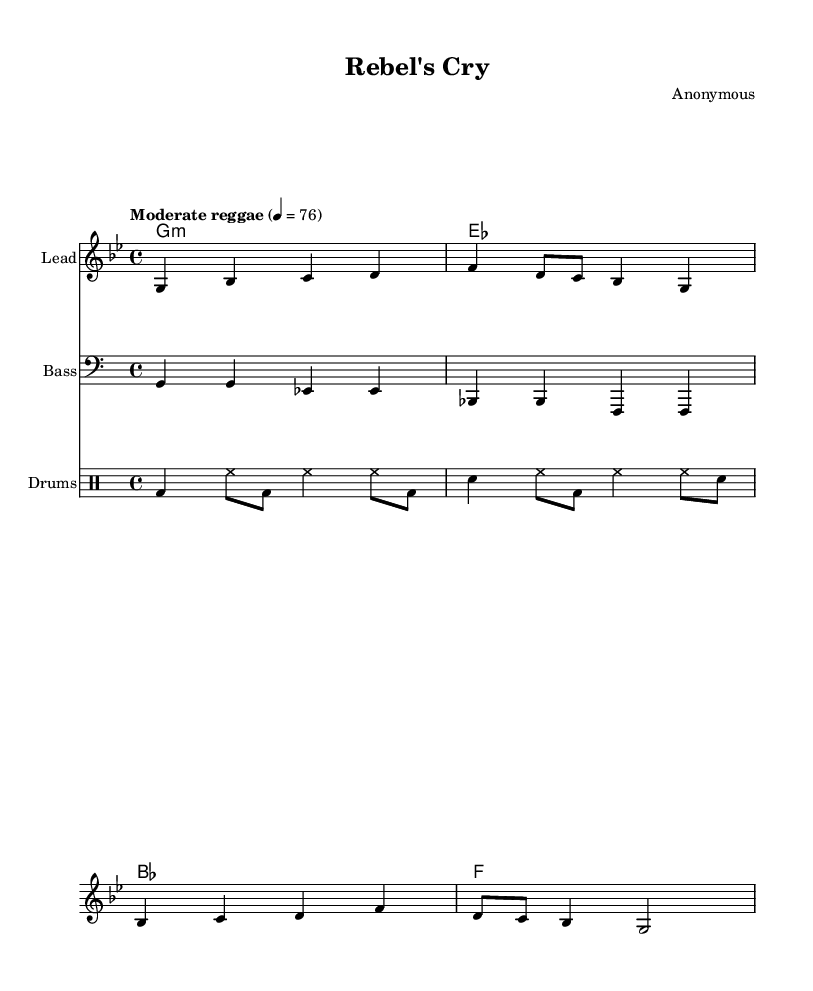What is the key signature of this music? The key signature indicated at the beginning of the sheet music is G minor, which has two flats: B flat and E flat.
Answer: G minor What is the time signature of this piece? The time signature shown in the sheet music is 4/4, meaning there are four beats in each measure and the quarter note gets one beat.
Answer: 4/4 What is the tempo marking for this song? The tempo marking states "Moderate reggae" with a metronome marking of 76, indicating a moderate pace typical of reggae music.
Answer: Moderate reggae How many measures does the melody section have? By counting the measures in the melody line, there are a total of 8 measures present.
Answer: 8 measures What instrument is designated for the drum part? The "DrumStaff" at the beginning of the drum section indicates that this part is specifically for drums, which includes the bass drum, snare, and hi-hat patterns.
Answer: Drums What is the main lyrical theme in the song based on the lyrics? The lyrics describe marching in the streets against the system, indicating themes of protest and civil disobedience.
Answer: Protest and civil disobedience What type of musical piece is "Rebel's Cry"? The song "Rebel's Cry" is categorized as a reggae track centered around social commentary, particularly on authority and civil rights issues.
Answer: Reggae track 